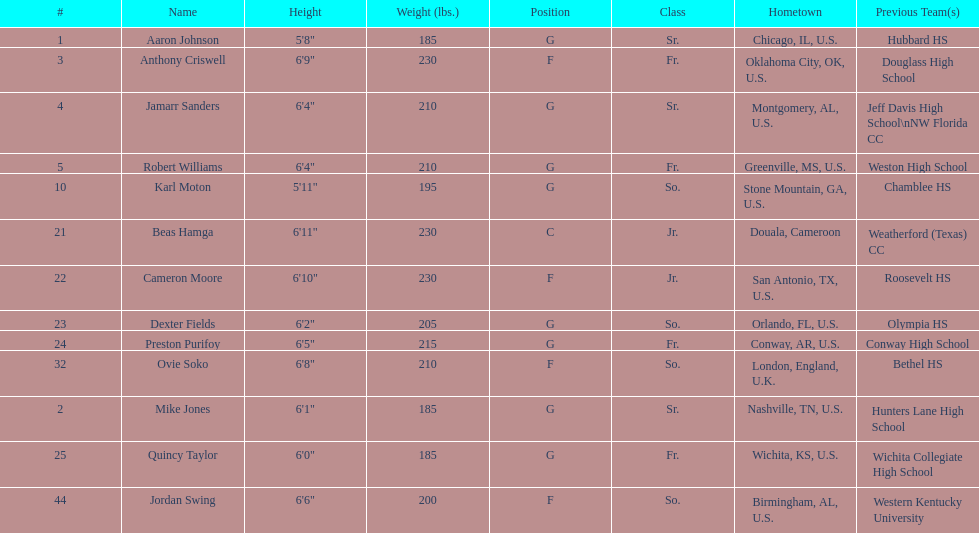What is the quantity of seniors on the team? 3. 